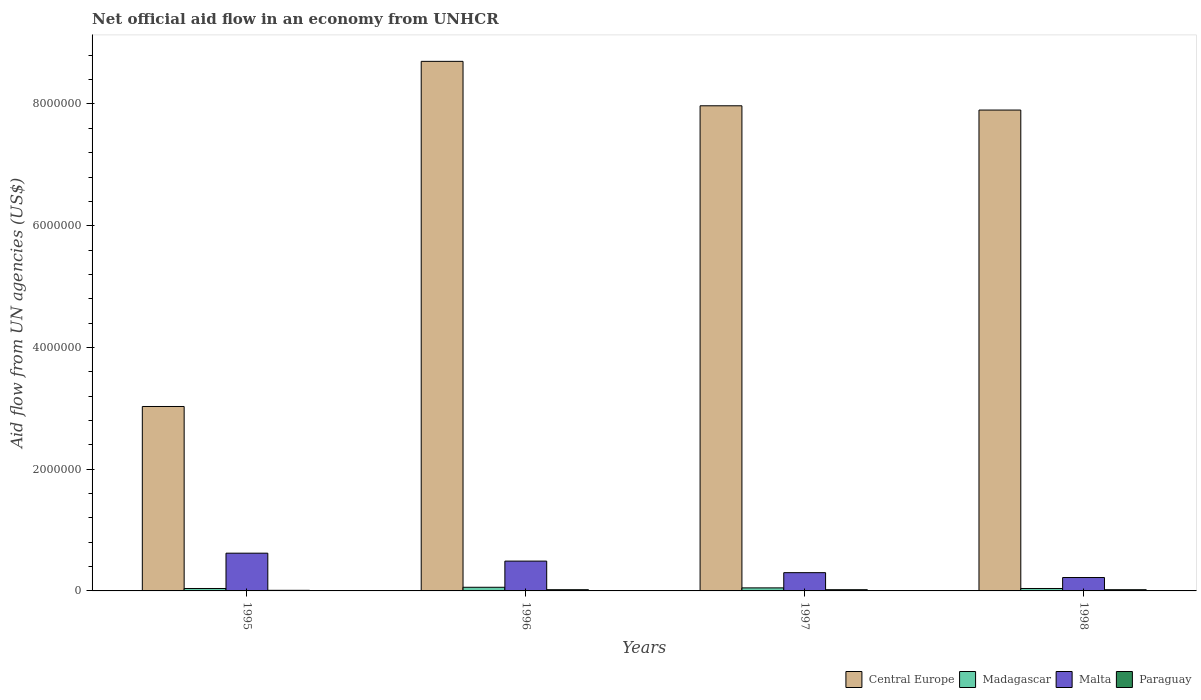Are the number of bars on each tick of the X-axis equal?
Offer a very short reply. Yes. How many bars are there on the 1st tick from the right?
Provide a short and direct response. 4. In how many cases, is the number of bars for a given year not equal to the number of legend labels?
Give a very brief answer. 0. What is the net official aid flow in Malta in 1995?
Give a very brief answer. 6.20e+05. Across all years, what is the minimum net official aid flow in Madagascar?
Give a very brief answer. 4.00e+04. In which year was the net official aid flow in Central Europe maximum?
Provide a succinct answer. 1996. What is the total net official aid flow in Paraguay in the graph?
Provide a succinct answer. 7.00e+04. What is the difference between the net official aid flow in Madagascar in 1997 and that in 1998?
Offer a very short reply. 10000. What is the difference between the net official aid flow in Paraguay in 1997 and the net official aid flow in Malta in 1996?
Offer a very short reply. -4.70e+05. What is the average net official aid flow in Madagascar per year?
Your answer should be very brief. 4.75e+04. In the year 1998, what is the difference between the net official aid flow in Malta and net official aid flow in Paraguay?
Provide a short and direct response. 2.00e+05. Is the net official aid flow in Central Europe in 1996 less than that in 1997?
Give a very brief answer. No. What is the difference between the highest and the lowest net official aid flow in Paraguay?
Keep it short and to the point. 10000. Is the sum of the net official aid flow in Central Europe in 1997 and 1998 greater than the maximum net official aid flow in Malta across all years?
Give a very brief answer. Yes. Is it the case that in every year, the sum of the net official aid flow in Malta and net official aid flow in Central Europe is greater than the sum of net official aid flow in Paraguay and net official aid flow in Madagascar?
Make the answer very short. Yes. What does the 2nd bar from the left in 1997 represents?
Your response must be concise. Madagascar. What does the 1st bar from the right in 1996 represents?
Provide a succinct answer. Paraguay. How many bars are there?
Offer a terse response. 16. Are all the bars in the graph horizontal?
Keep it short and to the point. No. Where does the legend appear in the graph?
Provide a succinct answer. Bottom right. What is the title of the graph?
Give a very brief answer. Net official aid flow in an economy from UNHCR. Does "Philippines" appear as one of the legend labels in the graph?
Provide a short and direct response. No. What is the label or title of the Y-axis?
Offer a very short reply. Aid flow from UN agencies (US$). What is the Aid flow from UN agencies (US$) in Central Europe in 1995?
Give a very brief answer. 3.03e+06. What is the Aid flow from UN agencies (US$) in Madagascar in 1995?
Provide a succinct answer. 4.00e+04. What is the Aid flow from UN agencies (US$) in Malta in 1995?
Your answer should be very brief. 6.20e+05. What is the Aid flow from UN agencies (US$) in Central Europe in 1996?
Provide a short and direct response. 8.70e+06. What is the Aid flow from UN agencies (US$) in Paraguay in 1996?
Ensure brevity in your answer.  2.00e+04. What is the Aid flow from UN agencies (US$) in Central Europe in 1997?
Make the answer very short. 7.97e+06. What is the Aid flow from UN agencies (US$) of Madagascar in 1997?
Offer a terse response. 5.00e+04. What is the Aid flow from UN agencies (US$) in Paraguay in 1997?
Your answer should be compact. 2.00e+04. What is the Aid flow from UN agencies (US$) in Central Europe in 1998?
Offer a terse response. 7.90e+06. Across all years, what is the maximum Aid flow from UN agencies (US$) in Central Europe?
Your response must be concise. 8.70e+06. Across all years, what is the maximum Aid flow from UN agencies (US$) of Madagascar?
Give a very brief answer. 6.00e+04. Across all years, what is the maximum Aid flow from UN agencies (US$) of Malta?
Keep it short and to the point. 6.20e+05. Across all years, what is the minimum Aid flow from UN agencies (US$) of Central Europe?
Provide a succinct answer. 3.03e+06. Across all years, what is the minimum Aid flow from UN agencies (US$) of Madagascar?
Make the answer very short. 4.00e+04. Across all years, what is the minimum Aid flow from UN agencies (US$) in Malta?
Provide a succinct answer. 2.20e+05. What is the total Aid flow from UN agencies (US$) of Central Europe in the graph?
Ensure brevity in your answer.  2.76e+07. What is the total Aid flow from UN agencies (US$) of Malta in the graph?
Your answer should be very brief. 1.63e+06. What is the difference between the Aid flow from UN agencies (US$) of Central Europe in 1995 and that in 1996?
Offer a terse response. -5.67e+06. What is the difference between the Aid flow from UN agencies (US$) in Madagascar in 1995 and that in 1996?
Offer a terse response. -2.00e+04. What is the difference between the Aid flow from UN agencies (US$) in Central Europe in 1995 and that in 1997?
Your answer should be very brief. -4.94e+06. What is the difference between the Aid flow from UN agencies (US$) of Paraguay in 1995 and that in 1997?
Make the answer very short. -10000. What is the difference between the Aid flow from UN agencies (US$) of Central Europe in 1995 and that in 1998?
Provide a succinct answer. -4.87e+06. What is the difference between the Aid flow from UN agencies (US$) in Malta in 1995 and that in 1998?
Your answer should be very brief. 4.00e+05. What is the difference between the Aid flow from UN agencies (US$) of Paraguay in 1995 and that in 1998?
Offer a very short reply. -10000. What is the difference between the Aid flow from UN agencies (US$) in Central Europe in 1996 and that in 1997?
Make the answer very short. 7.30e+05. What is the difference between the Aid flow from UN agencies (US$) in Madagascar in 1996 and that in 1997?
Your answer should be compact. 10000. What is the difference between the Aid flow from UN agencies (US$) of Paraguay in 1996 and that in 1997?
Offer a very short reply. 0. What is the difference between the Aid flow from UN agencies (US$) of Central Europe in 1996 and that in 1998?
Your response must be concise. 8.00e+05. What is the difference between the Aid flow from UN agencies (US$) of Madagascar in 1996 and that in 1998?
Your answer should be compact. 2.00e+04. What is the difference between the Aid flow from UN agencies (US$) in Paraguay in 1997 and that in 1998?
Keep it short and to the point. 0. What is the difference between the Aid flow from UN agencies (US$) of Central Europe in 1995 and the Aid flow from UN agencies (US$) of Madagascar in 1996?
Provide a succinct answer. 2.97e+06. What is the difference between the Aid flow from UN agencies (US$) of Central Europe in 1995 and the Aid flow from UN agencies (US$) of Malta in 1996?
Provide a short and direct response. 2.54e+06. What is the difference between the Aid flow from UN agencies (US$) in Central Europe in 1995 and the Aid flow from UN agencies (US$) in Paraguay in 1996?
Make the answer very short. 3.01e+06. What is the difference between the Aid flow from UN agencies (US$) in Madagascar in 1995 and the Aid flow from UN agencies (US$) in Malta in 1996?
Ensure brevity in your answer.  -4.50e+05. What is the difference between the Aid flow from UN agencies (US$) of Madagascar in 1995 and the Aid flow from UN agencies (US$) of Paraguay in 1996?
Give a very brief answer. 2.00e+04. What is the difference between the Aid flow from UN agencies (US$) of Malta in 1995 and the Aid flow from UN agencies (US$) of Paraguay in 1996?
Offer a terse response. 6.00e+05. What is the difference between the Aid flow from UN agencies (US$) of Central Europe in 1995 and the Aid flow from UN agencies (US$) of Madagascar in 1997?
Make the answer very short. 2.98e+06. What is the difference between the Aid flow from UN agencies (US$) in Central Europe in 1995 and the Aid flow from UN agencies (US$) in Malta in 1997?
Your answer should be very brief. 2.73e+06. What is the difference between the Aid flow from UN agencies (US$) in Central Europe in 1995 and the Aid flow from UN agencies (US$) in Paraguay in 1997?
Keep it short and to the point. 3.01e+06. What is the difference between the Aid flow from UN agencies (US$) of Madagascar in 1995 and the Aid flow from UN agencies (US$) of Paraguay in 1997?
Your answer should be compact. 2.00e+04. What is the difference between the Aid flow from UN agencies (US$) of Malta in 1995 and the Aid flow from UN agencies (US$) of Paraguay in 1997?
Provide a succinct answer. 6.00e+05. What is the difference between the Aid flow from UN agencies (US$) in Central Europe in 1995 and the Aid flow from UN agencies (US$) in Madagascar in 1998?
Provide a succinct answer. 2.99e+06. What is the difference between the Aid flow from UN agencies (US$) of Central Europe in 1995 and the Aid flow from UN agencies (US$) of Malta in 1998?
Make the answer very short. 2.81e+06. What is the difference between the Aid flow from UN agencies (US$) in Central Europe in 1995 and the Aid flow from UN agencies (US$) in Paraguay in 1998?
Offer a terse response. 3.01e+06. What is the difference between the Aid flow from UN agencies (US$) in Malta in 1995 and the Aid flow from UN agencies (US$) in Paraguay in 1998?
Make the answer very short. 6.00e+05. What is the difference between the Aid flow from UN agencies (US$) of Central Europe in 1996 and the Aid flow from UN agencies (US$) of Madagascar in 1997?
Your answer should be very brief. 8.65e+06. What is the difference between the Aid flow from UN agencies (US$) in Central Europe in 1996 and the Aid flow from UN agencies (US$) in Malta in 1997?
Ensure brevity in your answer.  8.40e+06. What is the difference between the Aid flow from UN agencies (US$) in Central Europe in 1996 and the Aid flow from UN agencies (US$) in Paraguay in 1997?
Give a very brief answer. 8.68e+06. What is the difference between the Aid flow from UN agencies (US$) of Madagascar in 1996 and the Aid flow from UN agencies (US$) of Malta in 1997?
Keep it short and to the point. -2.40e+05. What is the difference between the Aid flow from UN agencies (US$) of Madagascar in 1996 and the Aid flow from UN agencies (US$) of Paraguay in 1997?
Provide a succinct answer. 4.00e+04. What is the difference between the Aid flow from UN agencies (US$) of Malta in 1996 and the Aid flow from UN agencies (US$) of Paraguay in 1997?
Offer a very short reply. 4.70e+05. What is the difference between the Aid flow from UN agencies (US$) in Central Europe in 1996 and the Aid flow from UN agencies (US$) in Madagascar in 1998?
Keep it short and to the point. 8.66e+06. What is the difference between the Aid flow from UN agencies (US$) of Central Europe in 1996 and the Aid flow from UN agencies (US$) of Malta in 1998?
Ensure brevity in your answer.  8.48e+06. What is the difference between the Aid flow from UN agencies (US$) in Central Europe in 1996 and the Aid flow from UN agencies (US$) in Paraguay in 1998?
Your answer should be very brief. 8.68e+06. What is the difference between the Aid flow from UN agencies (US$) of Madagascar in 1996 and the Aid flow from UN agencies (US$) of Malta in 1998?
Your answer should be compact. -1.60e+05. What is the difference between the Aid flow from UN agencies (US$) in Central Europe in 1997 and the Aid flow from UN agencies (US$) in Madagascar in 1998?
Provide a short and direct response. 7.93e+06. What is the difference between the Aid flow from UN agencies (US$) of Central Europe in 1997 and the Aid flow from UN agencies (US$) of Malta in 1998?
Ensure brevity in your answer.  7.75e+06. What is the difference between the Aid flow from UN agencies (US$) of Central Europe in 1997 and the Aid flow from UN agencies (US$) of Paraguay in 1998?
Offer a terse response. 7.95e+06. What is the difference between the Aid flow from UN agencies (US$) of Madagascar in 1997 and the Aid flow from UN agencies (US$) of Malta in 1998?
Provide a short and direct response. -1.70e+05. What is the average Aid flow from UN agencies (US$) of Central Europe per year?
Your answer should be very brief. 6.90e+06. What is the average Aid flow from UN agencies (US$) of Madagascar per year?
Offer a terse response. 4.75e+04. What is the average Aid flow from UN agencies (US$) of Malta per year?
Keep it short and to the point. 4.08e+05. What is the average Aid flow from UN agencies (US$) of Paraguay per year?
Your answer should be compact. 1.75e+04. In the year 1995, what is the difference between the Aid flow from UN agencies (US$) of Central Europe and Aid flow from UN agencies (US$) of Madagascar?
Provide a short and direct response. 2.99e+06. In the year 1995, what is the difference between the Aid flow from UN agencies (US$) of Central Europe and Aid flow from UN agencies (US$) of Malta?
Offer a very short reply. 2.41e+06. In the year 1995, what is the difference between the Aid flow from UN agencies (US$) in Central Europe and Aid flow from UN agencies (US$) in Paraguay?
Provide a succinct answer. 3.02e+06. In the year 1995, what is the difference between the Aid flow from UN agencies (US$) of Madagascar and Aid flow from UN agencies (US$) of Malta?
Ensure brevity in your answer.  -5.80e+05. In the year 1995, what is the difference between the Aid flow from UN agencies (US$) of Madagascar and Aid flow from UN agencies (US$) of Paraguay?
Ensure brevity in your answer.  3.00e+04. In the year 1996, what is the difference between the Aid flow from UN agencies (US$) of Central Europe and Aid flow from UN agencies (US$) of Madagascar?
Provide a succinct answer. 8.64e+06. In the year 1996, what is the difference between the Aid flow from UN agencies (US$) in Central Europe and Aid flow from UN agencies (US$) in Malta?
Make the answer very short. 8.21e+06. In the year 1996, what is the difference between the Aid flow from UN agencies (US$) in Central Europe and Aid flow from UN agencies (US$) in Paraguay?
Provide a succinct answer. 8.68e+06. In the year 1996, what is the difference between the Aid flow from UN agencies (US$) in Madagascar and Aid flow from UN agencies (US$) in Malta?
Offer a very short reply. -4.30e+05. In the year 1997, what is the difference between the Aid flow from UN agencies (US$) of Central Europe and Aid flow from UN agencies (US$) of Madagascar?
Provide a succinct answer. 7.92e+06. In the year 1997, what is the difference between the Aid flow from UN agencies (US$) of Central Europe and Aid flow from UN agencies (US$) of Malta?
Provide a succinct answer. 7.67e+06. In the year 1997, what is the difference between the Aid flow from UN agencies (US$) of Central Europe and Aid flow from UN agencies (US$) of Paraguay?
Give a very brief answer. 7.95e+06. In the year 1997, what is the difference between the Aid flow from UN agencies (US$) of Madagascar and Aid flow from UN agencies (US$) of Malta?
Your answer should be very brief. -2.50e+05. In the year 1998, what is the difference between the Aid flow from UN agencies (US$) of Central Europe and Aid flow from UN agencies (US$) of Madagascar?
Keep it short and to the point. 7.86e+06. In the year 1998, what is the difference between the Aid flow from UN agencies (US$) in Central Europe and Aid flow from UN agencies (US$) in Malta?
Make the answer very short. 7.68e+06. In the year 1998, what is the difference between the Aid flow from UN agencies (US$) in Central Europe and Aid flow from UN agencies (US$) in Paraguay?
Your answer should be very brief. 7.88e+06. In the year 1998, what is the difference between the Aid flow from UN agencies (US$) in Madagascar and Aid flow from UN agencies (US$) in Malta?
Offer a very short reply. -1.80e+05. In the year 1998, what is the difference between the Aid flow from UN agencies (US$) in Madagascar and Aid flow from UN agencies (US$) in Paraguay?
Your answer should be very brief. 2.00e+04. In the year 1998, what is the difference between the Aid flow from UN agencies (US$) in Malta and Aid flow from UN agencies (US$) in Paraguay?
Your answer should be very brief. 2.00e+05. What is the ratio of the Aid flow from UN agencies (US$) of Central Europe in 1995 to that in 1996?
Make the answer very short. 0.35. What is the ratio of the Aid flow from UN agencies (US$) in Madagascar in 1995 to that in 1996?
Your response must be concise. 0.67. What is the ratio of the Aid flow from UN agencies (US$) in Malta in 1995 to that in 1996?
Provide a succinct answer. 1.27. What is the ratio of the Aid flow from UN agencies (US$) of Paraguay in 1995 to that in 1996?
Give a very brief answer. 0.5. What is the ratio of the Aid flow from UN agencies (US$) of Central Europe in 1995 to that in 1997?
Make the answer very short. 0.38. What is the ratio of the Aid flow from UN agencies (US$) in Madagascar in 1995 to that in 1997?
Provide a succinct answer. 0.8. What is the ratio of the Aid flow from UN agencies (US$) in Malta in 1995 to that in 1997?
Offer a terse response. 2.07. What is the ratio of the Aid flow from UN agencies (US$) in Central Europe in 1995 to that in 1998?
Offer a very short reply. 0.38. What is the ratio of the Aid flow from UN agencies (US$) in Madagascar in 1995 to that in 1998?
Offer a terse response. 1. What is the ratio of the Aid flow from UN agencies (US$) in Malta in 1995 to that in 1998?
Ensure brevity in your answer.  2.82. What is the ratio of the Aid flow from UN agencies (US$) of Paraguay in 1995 to that in 1998?
Make the answer very short. 0.5. What is the ratio of the Aid flow from UN agencies (US$) in Central Europe in 1996 to that in 1997?
Give a very brief answer. 1.09. What is the ratio of the Aid flow from UN agencies (US$) in Malta in 1996 to that in 1997?
Give a very brief answer. 1.63. What is the ratio of the Aid flow from UN agencies (US$) in Central Europe in 1996 to that in 1998?
Your response must be concise. 1.1. What is the ratio of the Aid flow from UN agencies (US$) in Madagascar in 1996 to that in 1998?
Your answer should be compact. 1.5. What is the ratio of the Aid flow from UN agencies (US$) of Malta in 1996 to that in 1998?
Your answer should be very brief. 2.23. What is the ratio of the Aid flow from UN agencies (US$) in Paraguay in 1996 to that in 1998?
Offer a very short reply. 1. What is the ratio of the Aid flow from UN agencies (US$) in Central Europe in 1997 to that in 1998?
Keep it short and to the point. 1.01. What is the ratio of the Aid flow from UN agencies (US$) in Madagascar in 1997 to that in 1998?
Your response must be concise. 1.25. What is the ratio of the Aid flow from UN agencies (US$) in Malta in 1997 to that in 1998?
Offer a terse response. 1.36. What is the difference between the highest and the second highest Aid flow from UN agencies (US$) of Central Europe?
Make the answer very short. 7.30e+05. What is the difference between the highest and the second highest Aid flow from UN agencies (US$) in Malta?
Your response must be concise. 1.30e+05. What is the difference between the highest and the lowest Aid flow from UN agencies (US$) in Central Europe?
Your answer should be very brief. 5.67e+06. What is the difference between the highest and the lowest Aid flow from UN agencies (US$) of Madagascar?
Keep it short and to the point. 2.00e+04. What is the difference between the highest and the lowest Aid flow from UN agencies (US$) in Paraguay?
Offer a very short reply. 10000. 